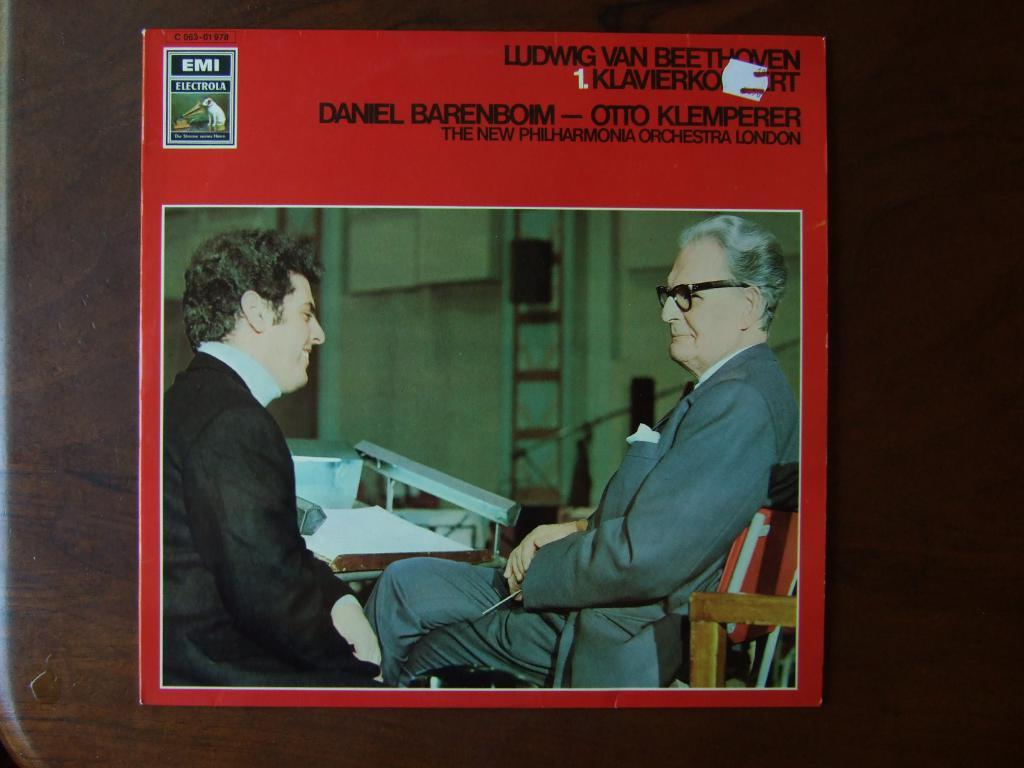What is the main subject of the image? The main subject of the image is a cover photo. Where is the cover photo located? The cover photo is placed on a table. Are there any people in the image? Yes, there are two persons sitting on chairs in the image. What type of furniture is present in the image? There is a table in the image. What type of tin can be seen in the image? There is no tin present in the image. Is there any poison visible in the image? There is no poison visible in the image. 